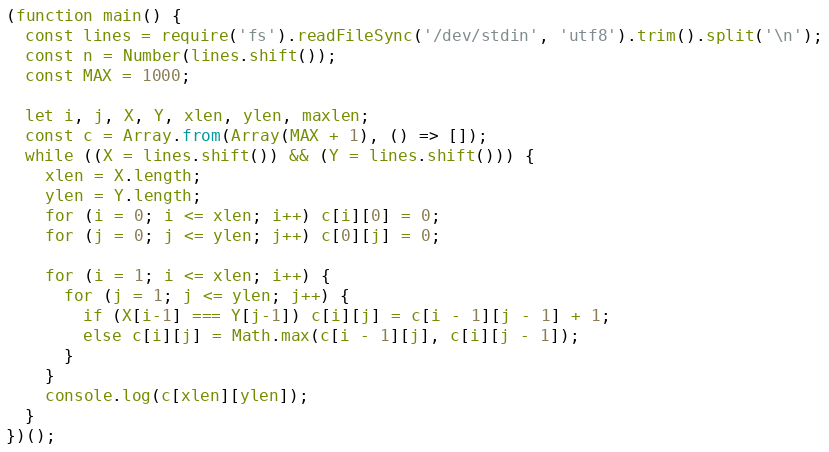<code> <loc_0><loc_0><loc_500><loc_500><_JavaScript_>(function main() {
  const lines = require('fs').readFileSync('/dev/stdin', 'utf8').trim().split('\n');
  const n = Number(lines.shift());
  const MAX = 1000;

  let i, j, X, Y, xlen, ylen, maxlen;
  const c = Array.from(Array(MAX + 1), () => []);
  while ((X = lines.shift()) && (Y = lines.shift())) {
    xlen = X.length;
    ylen = Y.length;
    for (i = 0; i <= xlen; i++) c[i][0] = 0;
    for (j = 0; j <= ylen; j++) c[0][j] = 0;

    for (i = 1; i <= xlen; i++) {
      for (j = 1; j <= ylen; j++) {
        if (X[i-1] === Y[j-1]) c[i][j] = c[i - 1][j - 1] + 1;
        else c[i][j] = Math.max(c[i - 1][j], c[i][j - 1]);
      }
    }
    console.log(c[xlen][ylen]);
  }
})();

</code> 